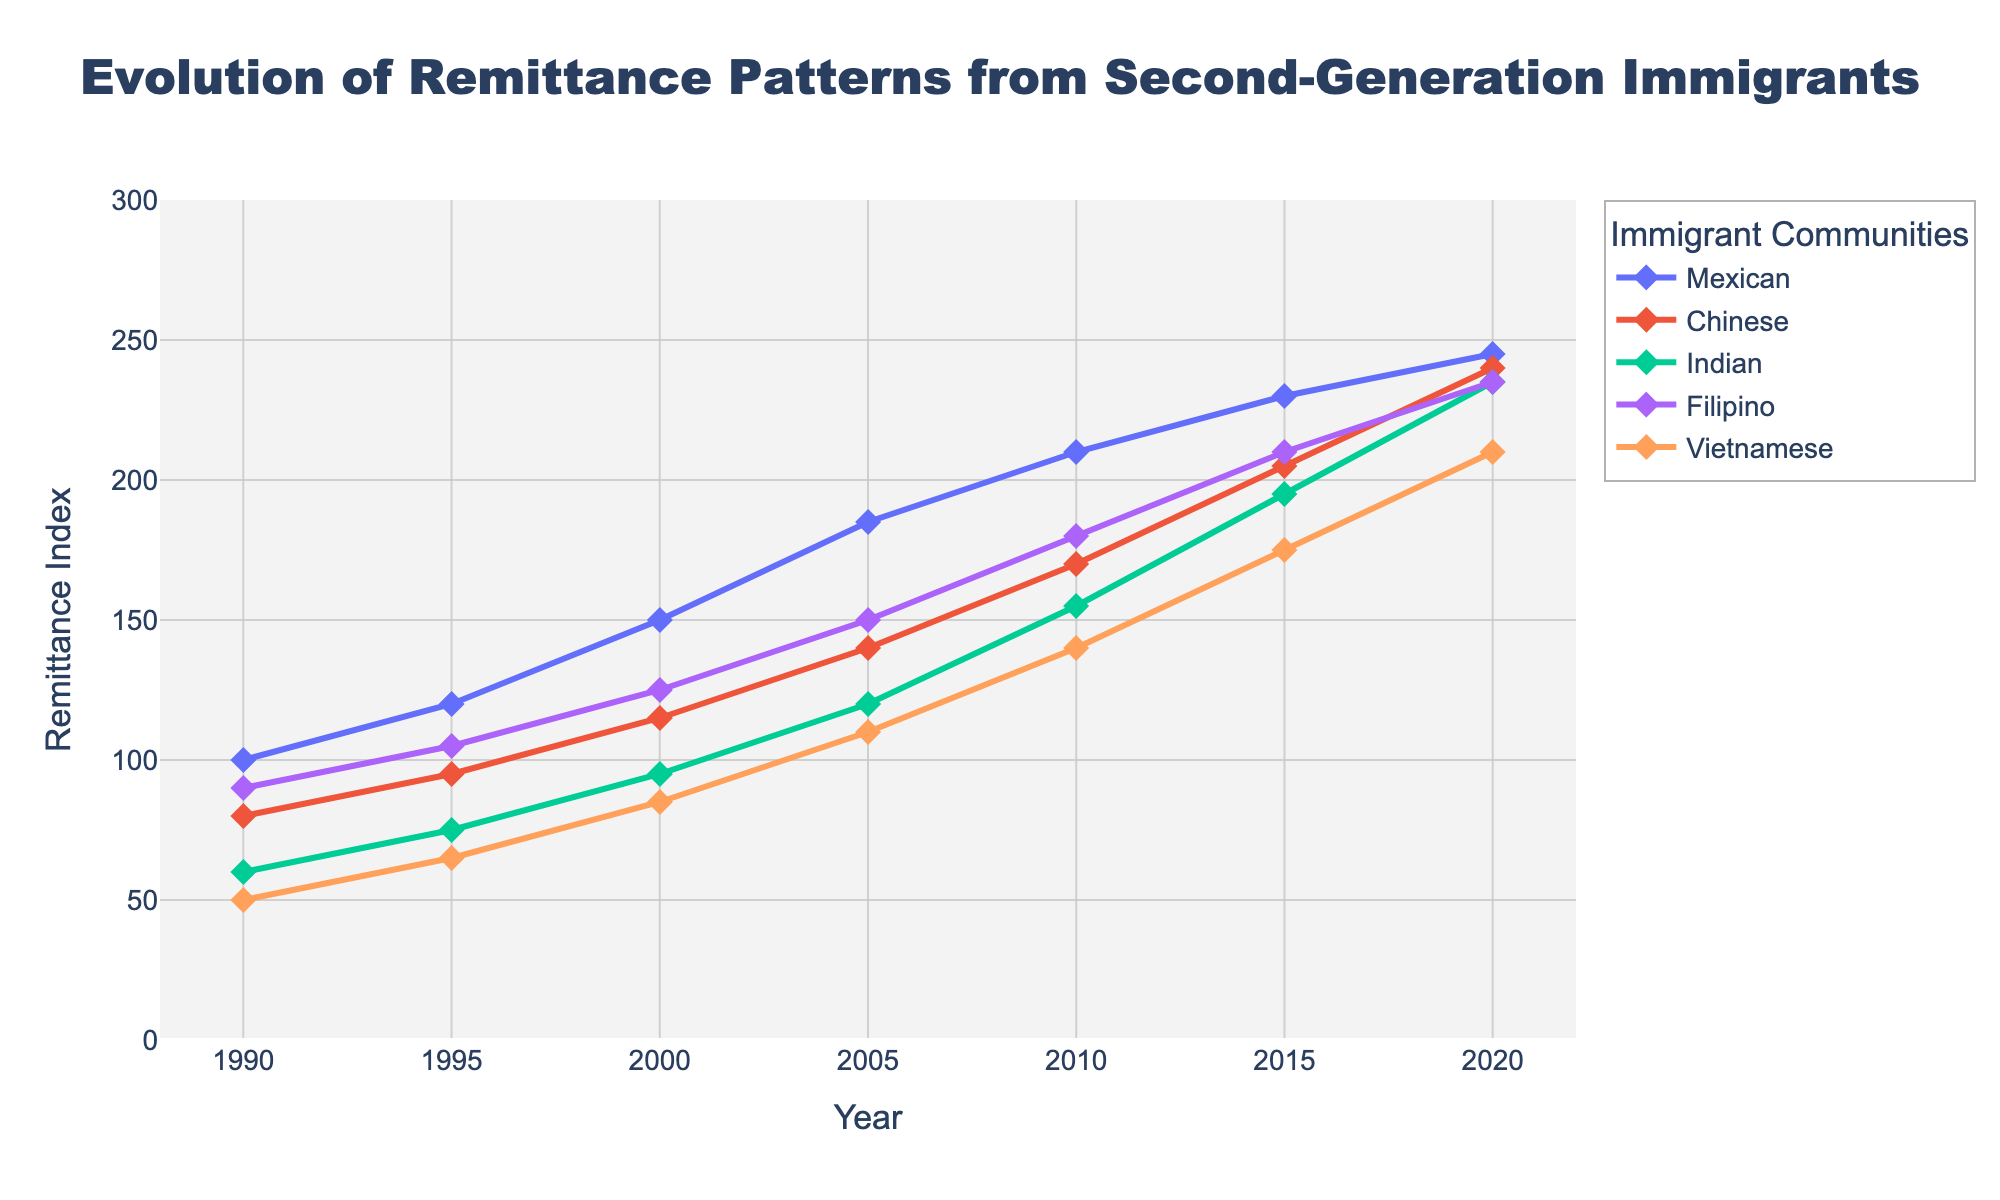What's the overall trend in remittance patterns from second-generation Mexican immigrants between 1990 and 2020? The remittance index for Mexican immigrants consistently increases over the years. Starting from 100 in 1990, it rises to 245 in 2020, demonstrating a clear upward trend.
Answer: Upward In which year did Indian second-generation immigrants' remittance index surpass 100? By observing the line for Indian immigrants, we see that the index surpasses 100 around the year 2000, remaining above it afterward.
Answer: 2000 Which immigrant community had the highest remittance index by 2020? In the year 2020, observing the lines, the Indian immigrants have the highest remittance index at 235.
Answer: Indian Compare the remittance index of Chinese and Filipino communities in the year 2010. Which was higher? In 2010, the plot shows that the remittance index for Chinese immigrants is around 170, whereas for Filipino immigrants, it's around 180.
Answer: Filipino What is the average remittance index of Filipino immigrants for the years provided? Summing the values for Filipino immigrants (90 + 105 + 125 + 150 + 180 + 210 + 235) gives 1095. Dividing by the 7 years provided, the average is calculated.
Answer: 156.43 What is the difference in the remittance index between Vietnamese and Mexican communities in 2005? From the graph, in 2005, the remittance index for Vietnamese immigrants is 110, and for Mexican immigrants, it is 185. The difference is 185 - 110.
Answer: 75 Which community shows the most significant increase in remittance index from 1990 to 2020? Calculating the differences for each community: Mexican (245-100=145), Chinese (240-80=160), Indian (235-60=175), Filipino (235-90=145), and Vietnamese (210-50=160). Indian immigrants show the most significant increase.
Answer: Indian Between 2000 and 2005, which immigrant community exhibited the largest growth in remittance index? Observing the rise between these years for each community: Mexican (185-150=35), Chinese (140-115=25), Indian (120-95=25), Filipino (150-125=25), Vietnamese (110-85=25). Mexican immigrants exhibited the largest growth.
Answer: Mexican What is the range of remittance index values for the Chinese community over the provided years? The range is calculated using the minimum and maximum values for the Chinese community (80 to 240). The range is 240 - 80.
Answer: 160 How does the remittance index for Vietnamese immigrants in 1995 compare to that in 2015? The remittance index for Vietnamese immigrants in 1995 is 65, while in 2015, it is 175. Comparing these values shows significant growth.
Answer: Vietnamese índices markedly increased 